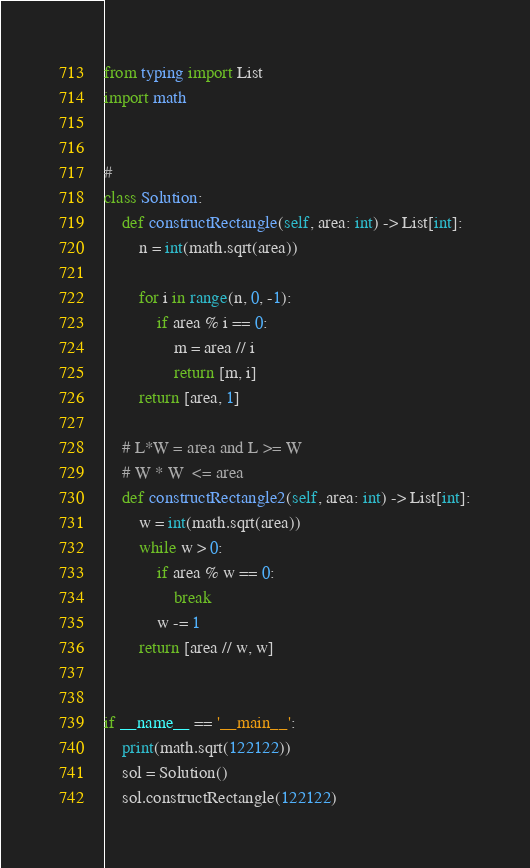<code> <loc_0><loc_0><loc_500><loc_500><_Python_>from typing import List
import math


#
class Solution:
    def constructRectangle(self, area: int) -> List[int]:
        n = int(math.sqrt(area))

        for i in range(n, 0, -1):
            if area % i == 0:
                m = area // i
                return [m, i]
        return [area, 1]

    # L*W = area and L >= W
    # W * W  <= area
    def constructRectangle2(self, area: int) -> List[int]:
        w = int(math.sqrt(area))
        while w > 0:
            if area % w == 0:
                break
            w -= 1
        return [area // w, w]


if __name__ == '__main__':
    print(math.sqrt(122122))
    sol = Solution()
    sol.constructRectangle(122122)
</code> 